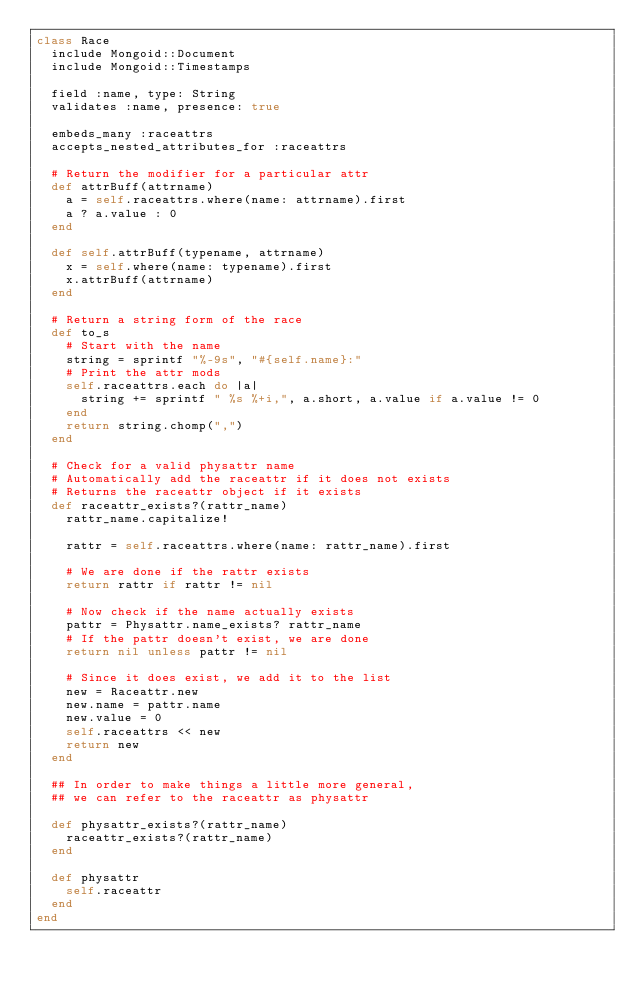<code> <loc_0><loc_0><loc_500><loc_500><_Ruby_>class Race
  include Mongoid::Document
  include Mongoid::Timestamps

  field :name, type: String
  validates :name, presence: true

  embeds_many :raceattrs
  accepts_nested_attributes_for :raceattrs

  # Return the modifier for a particular attr
  def attrBuff(attrname)
    a = self.raceattrs.where(name: attrname).first
    a ? a.value : 0
  end

  def self.attrBuff(typename, attrname)
    x = self.where(name: typename).first
    x.attrBuff(attrname)
  end

  # Return a string form of the race
  def to_s
    # Start with the name
    string = sprintf "%-9s", "#{self.name}:"
    # Print the attr mods
    self.raceattrs.each do |a|
      string += sprintf " %s %+i,", a.short, a.value if a.value != 0
    end
    return string.chomp(",")
  end

  # Check for a valid physattr name
  # Automatically add the raceattr if it does not exists
  # Returns the raceattr object if it exists
  def raceattr_exists?(rattr_name)
    rattr_name.capitalize!

    rattr = self.raceattrs.where(name: rattr_name).first

    # We are done if the rattr exists
    return rattr if rattr != nil

    # Now check if the name actually exists
    pattr = Physattr.name_exists? rattr_name
    # If the pattr doesn't exist, we are done
    return nil unless pattr != nil

    # Since it does exist, we add it to the list
    new = Raceattr.new
    new.name = pattr.name
    new.value = 0
    self.raceattrs << new
    return new
  end

  ## In order to make things a little more general,
  ## we can refer to the raceattr as physattr

  def physattr_exists?(rattr_name)
    raceattr_exists?(rattr_name)
  end

  def physattr
    self.raceattr
  end
end
</code> 